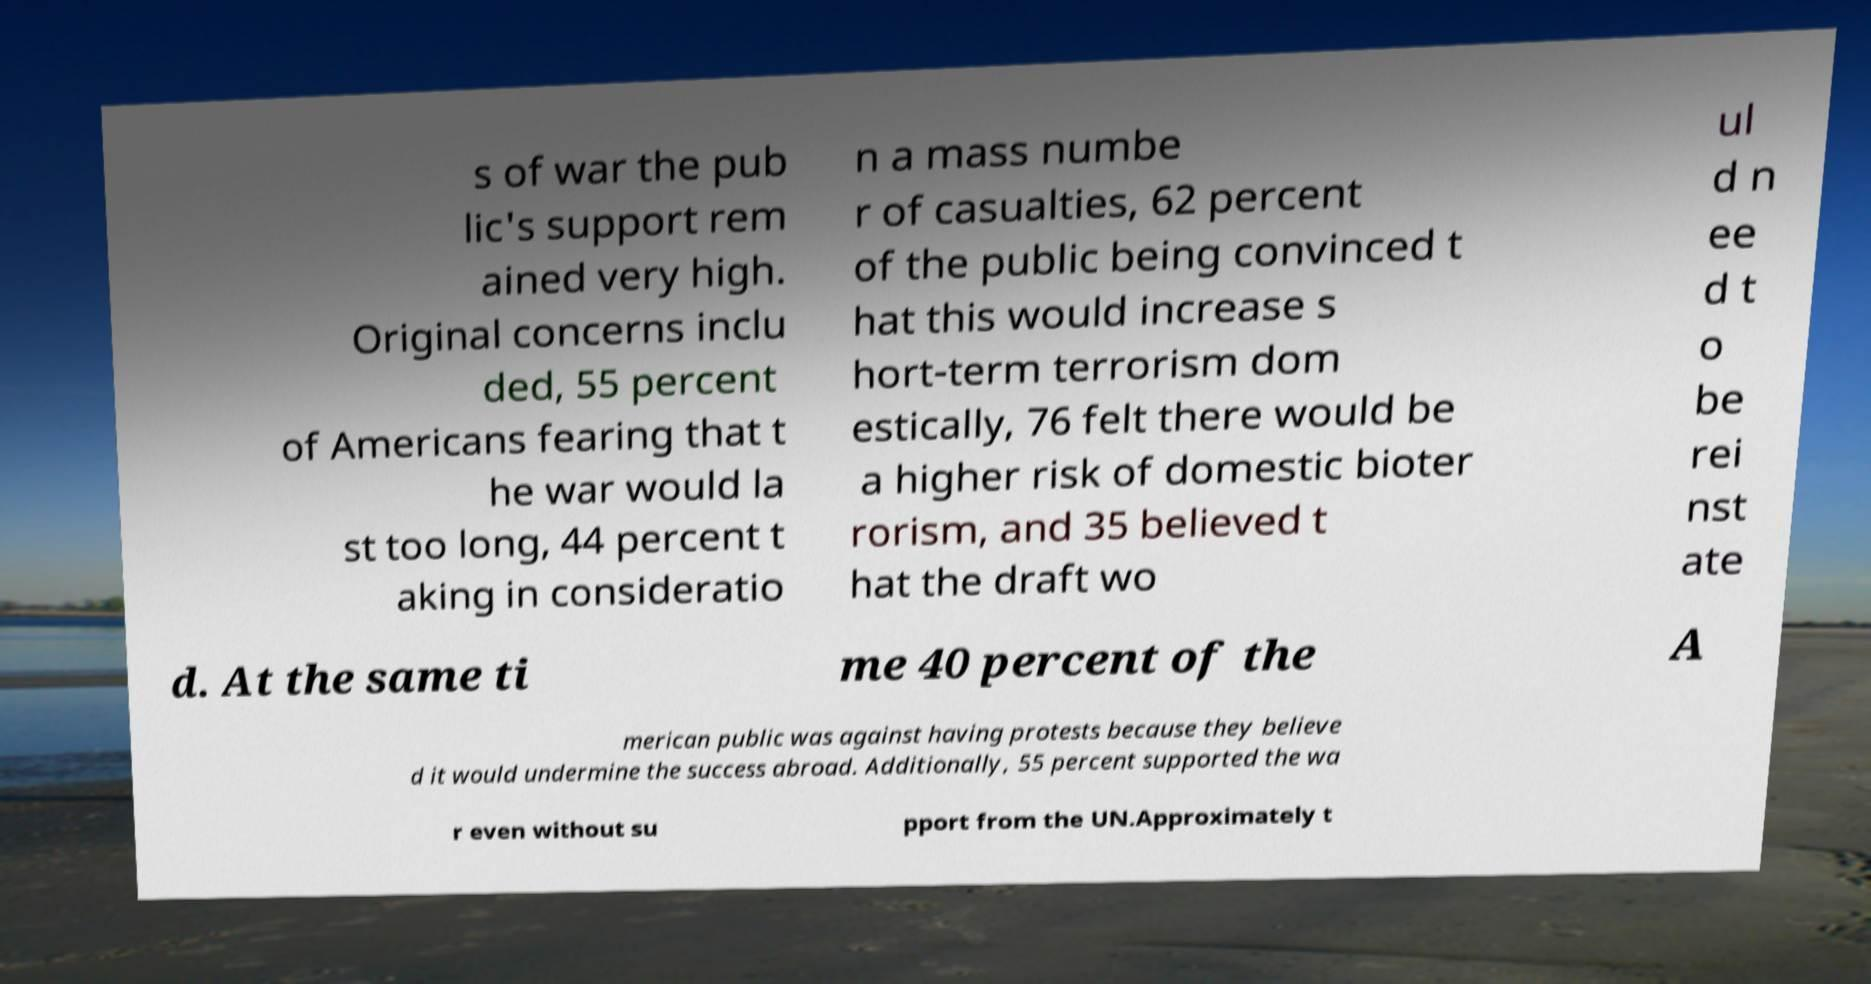For documentation purposes, I need the text within this image transcribed. Could you provide that? s of war the pub lic's support rem ained very high. Original concerns inclu ded, 55 percent of Americans fearing that t he war would la st too long, 44 percent t aking in consideratio n a mass numbe r of casualties, 62 percent of the public being convinced t hat this would increase s hort-term terrorism dom estically, 76 felt there would be a higher risk of domestic bioter rorism, and 35 believed t hat the draft wo ul d n ee d t o be rei nst ate d. At the same ti me 40 percent of the A merican public was against having protests because they believe d it would undermine the success abroad. Additionally, 55 percent supported the wa r even without su pport from the UN.Approximately t 